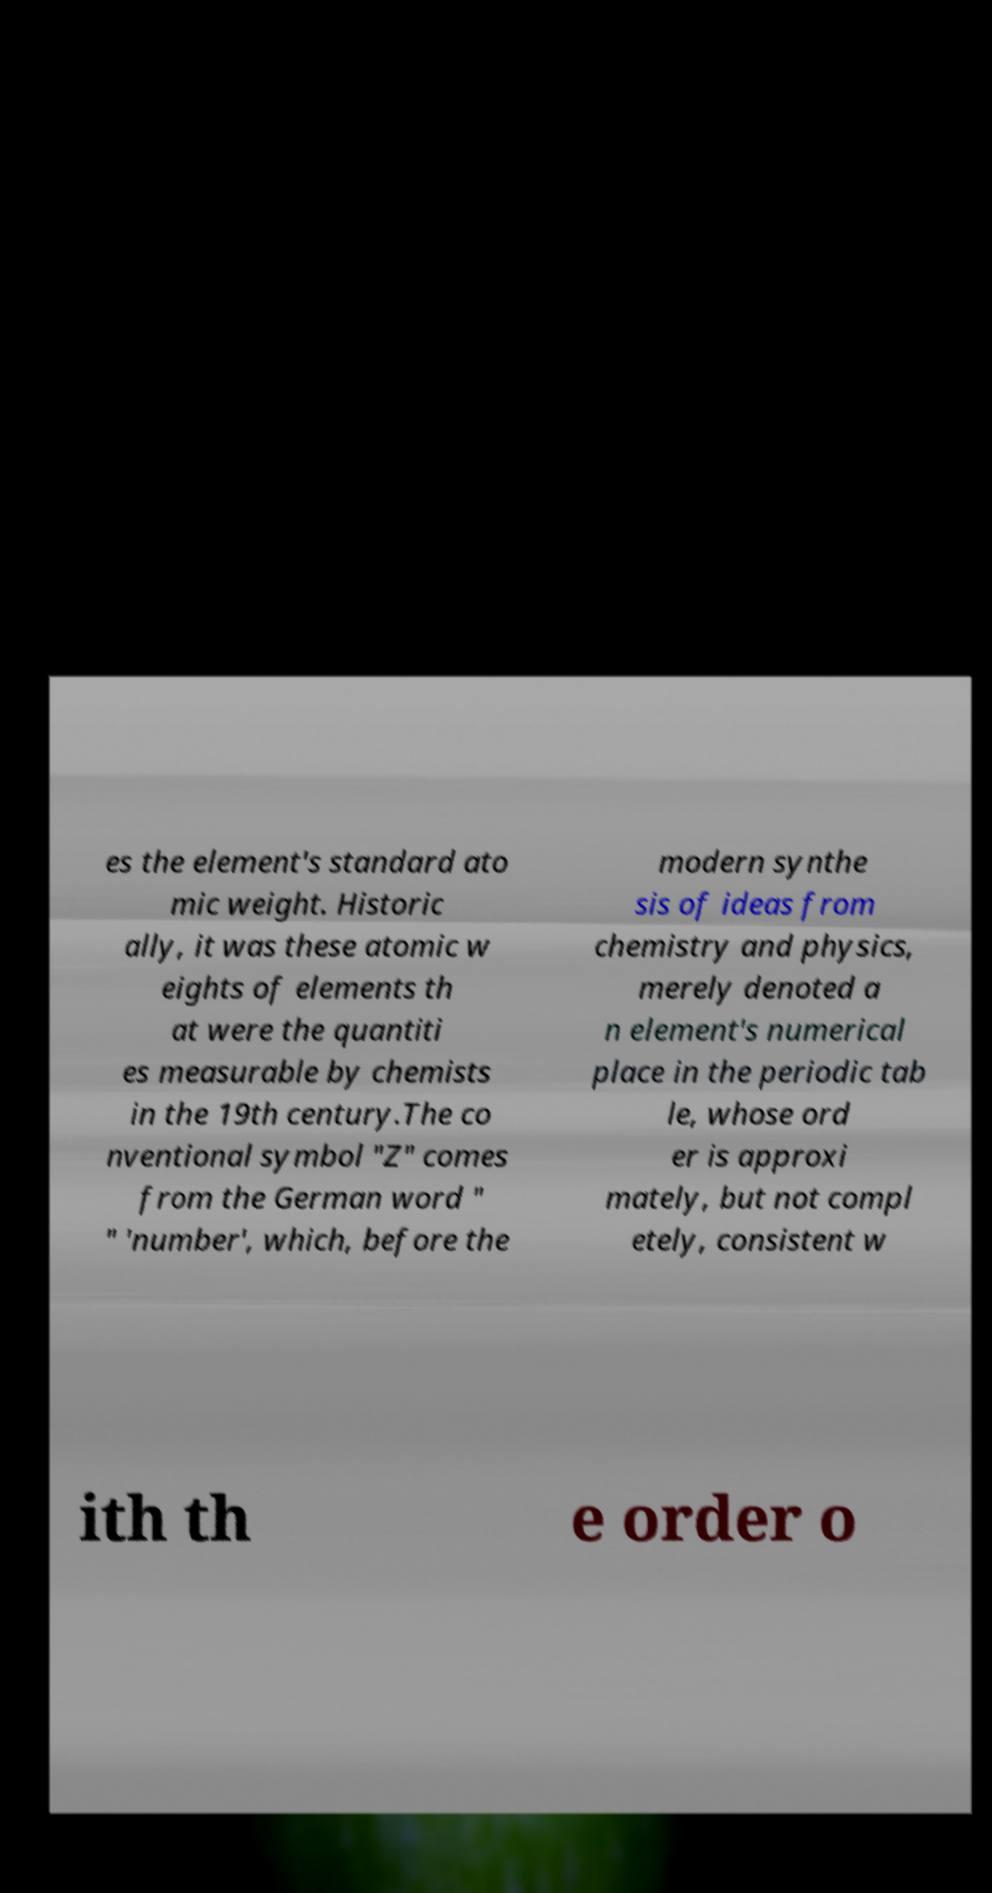Can you read and provide the text displayed in the image?This photo seems to have some interesting text. Can you extract and type it out for me? es the element's standard ato mic weight. Historic ally, it was these atomic w eights of elements th at were the quantiti es measurable by chemists in the 19th century.The co nventional symbol "Z" comes from the German word " " 'number', which, before the modern synthe sis of ideas from chemistry and physics, merely denoted a n element's numerical place in the periodic tab le, whose ord er is approxi mately, but not compl etely, consistent w ith th e order o 